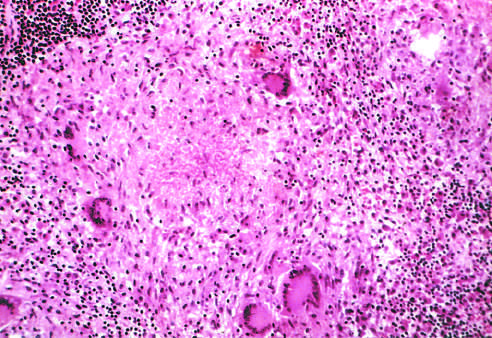s an area of central necrosis surrounded by multiple multinucleate giant cells, epithelioid cells, and lymphocytes?
Answer the question using a single word or phrase. Yes 